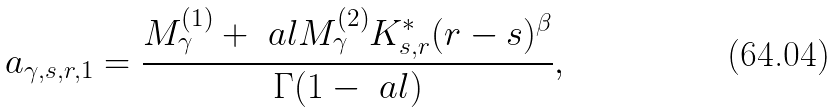<formula> <loc_0><loc_0><loc_500><loc_500>a _ { \gamma , s , r , 1 } = \frac { M ^ { ( 1 ) } _ { \gamma } + \ a l M ^ { ( 2 ) } _ { \gamma } K ^ { * } _ { s , r } ( r - s ) ^ { \beta } } { \Gamma ( 1 - \ a l ) } ,</formula> 